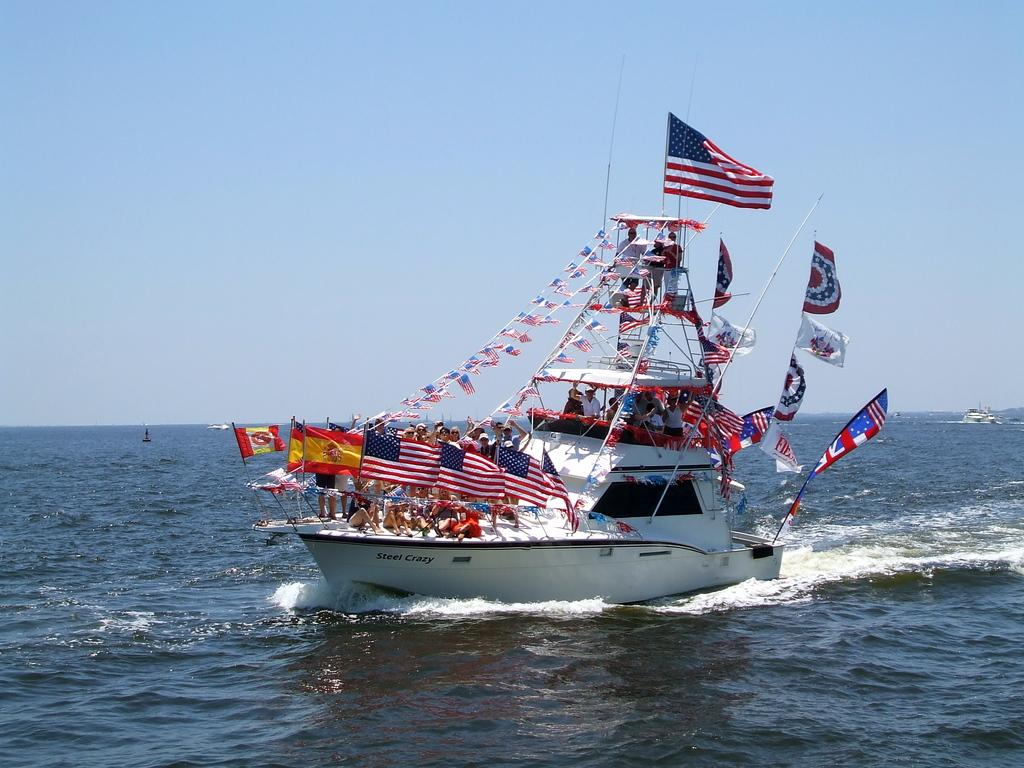<image>
Offer a succinct explanation of the picture presented. White boat that says Steel Crazy on the bottom. 